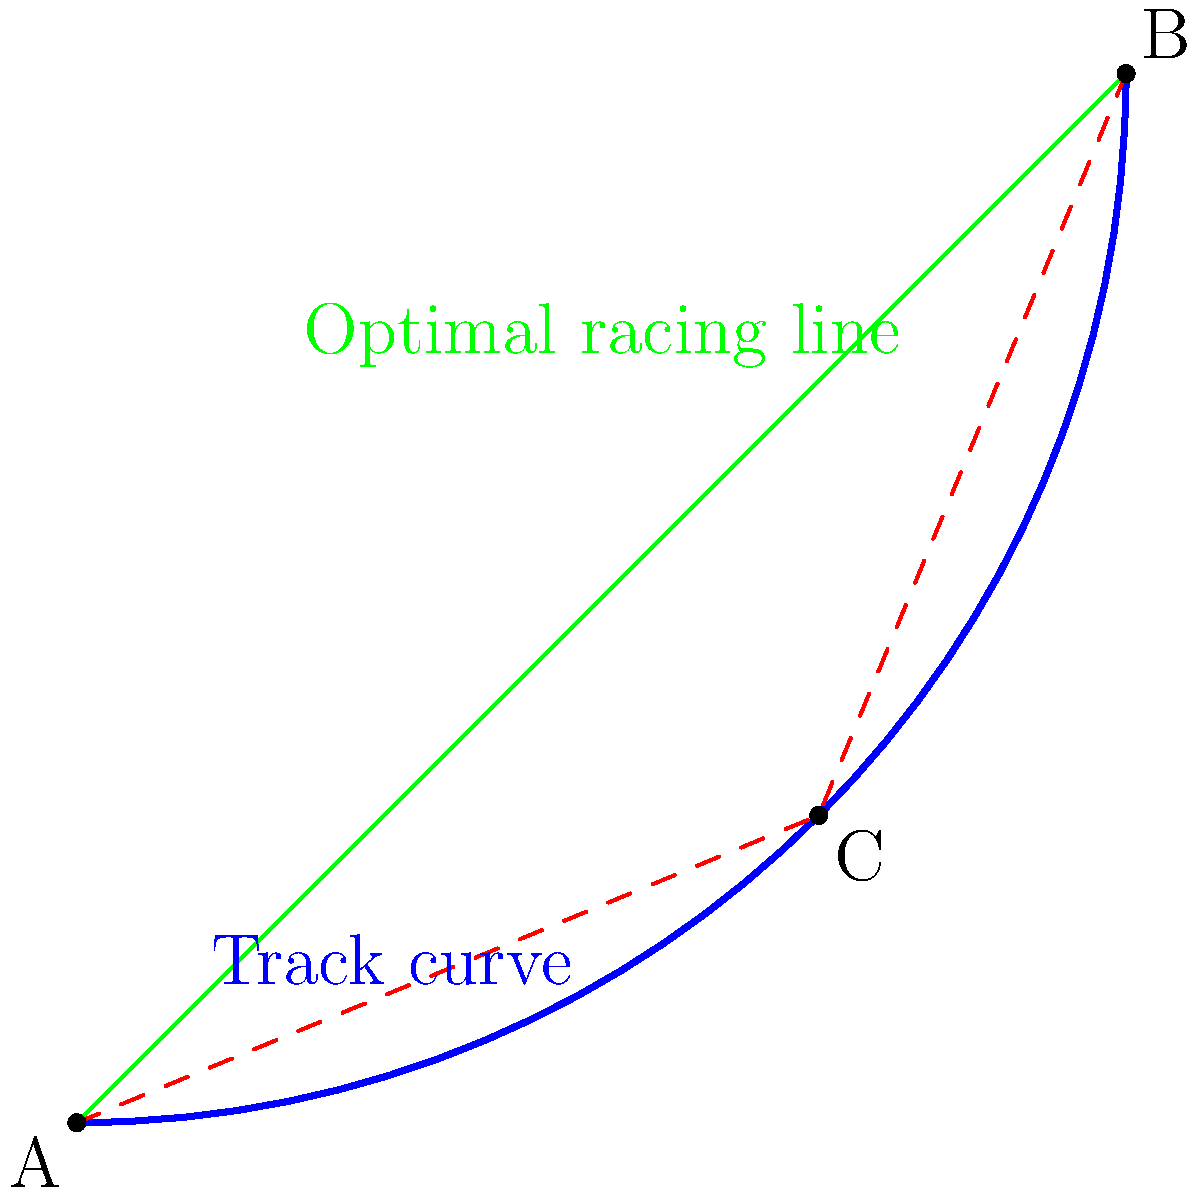In the diagram above, a curved section of a race track is shown from a top-down view. Point A represents the entry of the curve, point B the exit, and point C a point on the curve. The green line represents the optimal racing line. If the distance AC is 70 meters and CB is 60 meters, what is the approximate length saved by taking the optimal racing line (green) compared to following the curve of the track (blue), assuming the curve is a perfect arc? To solve this problem, we'll follow these steps:

1) First, we need to calculate the length of the optimal racing line (green line AB):
   Using the Pythagorean theorem: $AB = \sqrt{AC^2 + CB^2}$
   $AB = \sqrt{70^2 + 60^2} = \sqrt{4900 + 3600} = \sqrt{8500} \approx 92.2$ meters

2) Next, we need to calculate the length of the curved track (blue line):
   For a perfect arc, we can use the formula: $L = r\theta$
   where $L$ is the length of the arc, $r$ is the radius, and $\theta$ is the central angle in radians.

3) To find $r$ and $\theta$, we can use the properties of isosceles triangles:
   The perpendicular bisector of AB will pass through the center of the circle.
   This divides the triangle into two right triangles.

4) In one of these right triangles:
   $\sin(\theta/2) = (AB/2)/r$
   $r = (AB/2) / \sin(\theta/2)$

5) We can find $\theta/2$ using:
   $\cos(\theta/2) = (AC/2)/r = 35/r$

6) Combining these:
   $35/r = \cos(\arcsin(46.1/r))$

7) Solving this equation numerically gives $r \approx 58.3$ meters

8) We can then find $\theta$:
   $\theta = 2 \arcsin(46.1/58.3) \approx 1.85$ radians

9) The length of the arc is then:
   $L = r\theta = 58.3 * 1.85 \approx 107.9$ meters

10) The difference between the arc length and the optimal line is:
    $107.9 - 92.2 \approx 15.7$ meters
Answer: Approximately 15.7 meters 